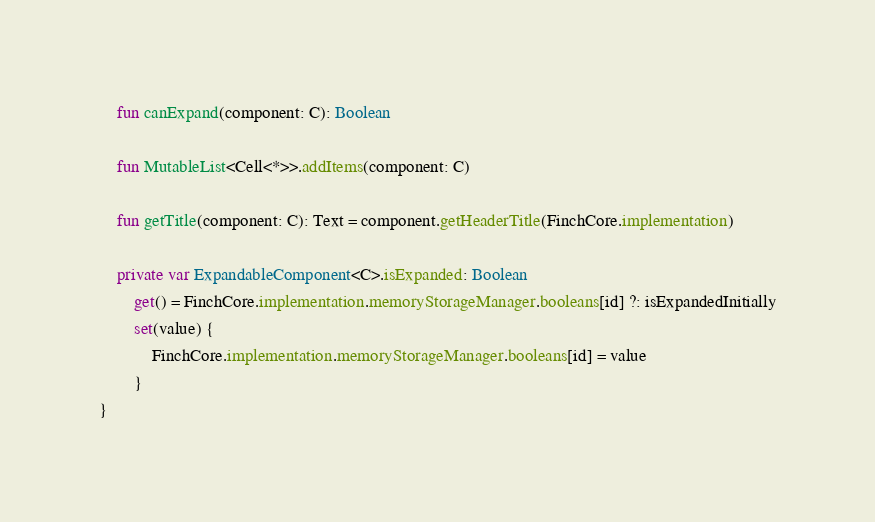<code> <loc_0><loc_0><loc_500><loc_500><_Kotlin_>    fun canExpand(component: C): Boolean

    fun MutableList<Cell<*>>.addItems(component: C)

    fun getTitle(component: C): Text = component.getHeaderTitle(FinchCore.implementation)

    private var ExpandableComponent<C>.isExpanded: Boolean
        get() = FinchCore.implementation.memoryStorageManager.booleans[id] ?: isExpandedInitially
        set(value) {
            FinchCore.implementation.memoryStorageManager.booleans[id] = value
        }
}
</code> 